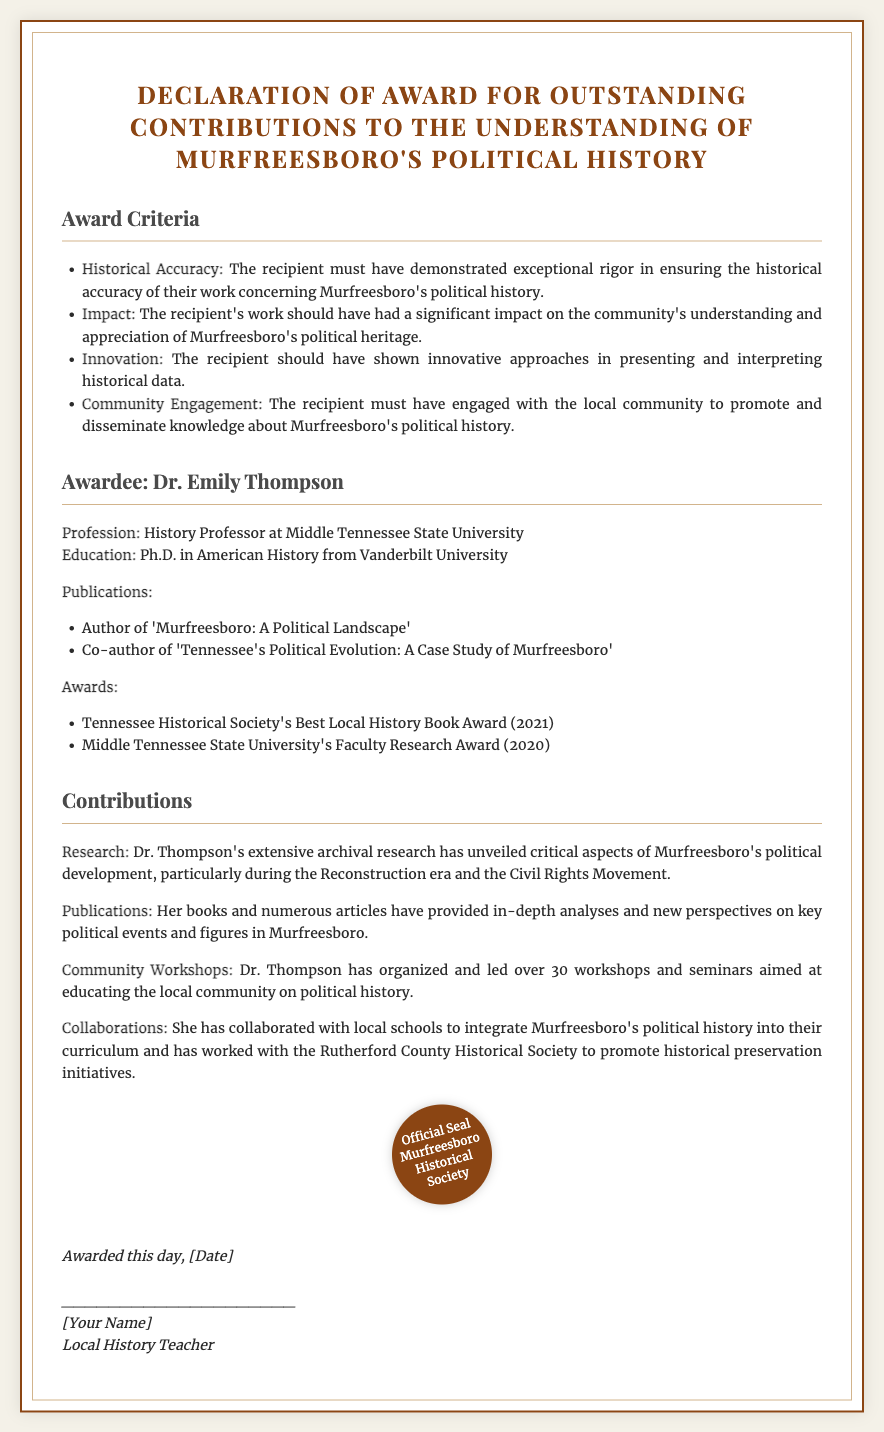What is the title of the award? The title of the award is mentioned at the top of the document.
Answer: Declaration of Award for Outstanding Contributions to the Understanding of Murfreesboro's Political History Who is the awardee? The awardee's name is clearly stated under the awardee section.
Answer: Dr. Emily Thompson What is Dr. Emily Thompson's profession? The document specifies Dr. Thompson's profession.
Answer: History Professor at Middle Tennessee State University How many workshops has Dr. Thompson organized? This information is provided in the contributions section of the document.
Answer: Over 30 What year did Dr. Thompson receive the Faculty Research Award? The date of the award is mentioned in the awards section of the document.
Answer: 2020 Which university did Dr. Thompson earn her Ph.D. from? The document includes educational background information about the awardee.
Answer: Vanderbilt University What is one of the publications authored by Dr. Thompson? This is listed in the publications section of the document.
Answer: Murfreesboro: A Political Landscape What is one of the criteria for the award? The award criteria are outlined in a specific section of the document.
Answer: Historical Accuracy What society issued the official seal? The document shows the seal at the bottom, indicating the issuing body.
Answer: Murfreesboro Historical Society 